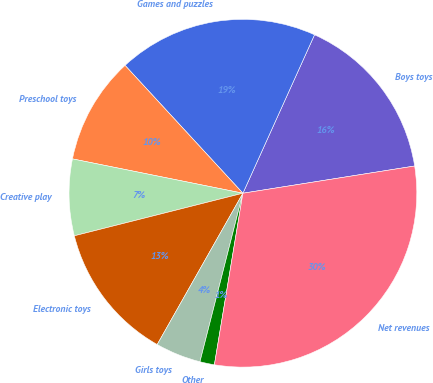Convert chart. <chart><loc_0><loc_0><loc_500><loc_500><pie_chart><fcel>Boys toys<fcel>Games and puzzles<fcel>Preschool toys<fcel>Creative play<fcel>Electronic toys<fcel>Girls toys<fcel>Other<fcel>Net revenues<nl><fcel>15.74%<fcel>18.61%<fcel>9.98%<fcel>7.1%<fcel>12.86%<fcel>4.23%<fcel>1.35%<fcel>30.12%<nl></chart> 